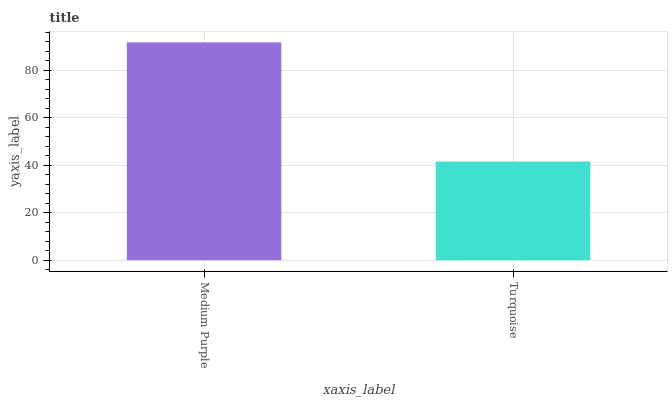Is Turquoise the minimum?
Answer yes or no. Yes. Is Medium Purple the maximum?
Answer yes or no. Yes. Is Turquoise the maximum?
Answer yes or no. No. Is Medium Purple greater than Turquoise?
Answer yes or no. Yes. Is Turquoise less than Medium Purple?
Answer yes or no. Yes. Is Turquoise greater than Medium Purple?
Answer yes or no. No. Is Medium Purple less than Turquoise?
Answer yes or no. No. Is Medium Purple the high median?
Answer yes or no. Yes. Is Turquoise the low median?
Answer yes or no. Yes. Is Turquoise the high median?
Answer yes or no. No. Is Medium Purple the low median?
Answer yes or no. No. 